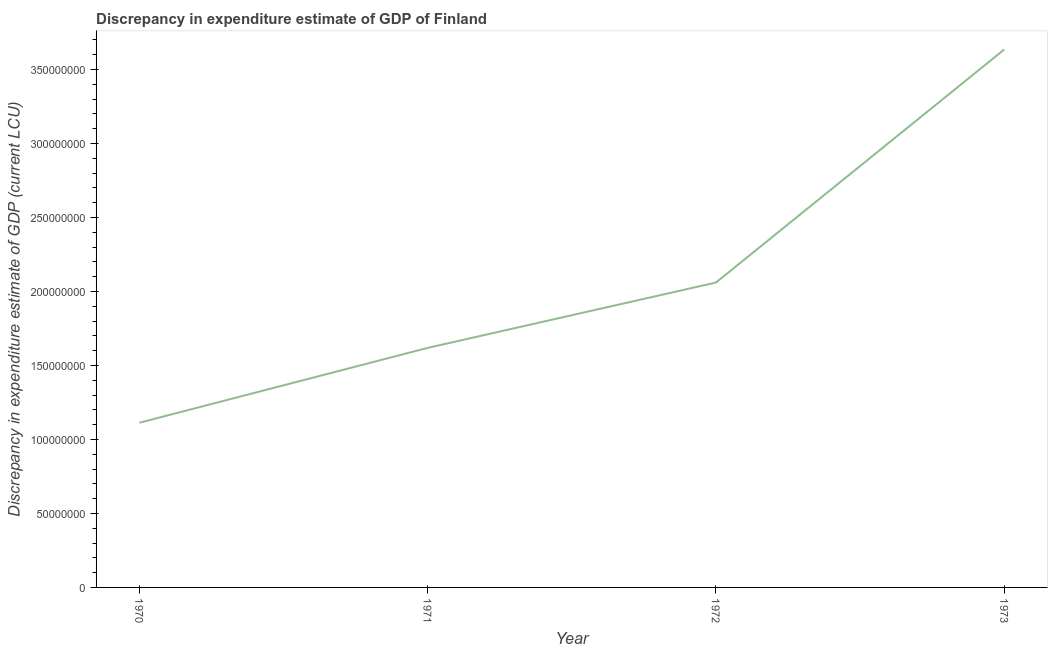What is the discrepancy in expenditure estimate of gdp in 1972?
Give a very brief answer. 2.06e+08. Across all years, what is the maximum discrepancy in expenditure estimate of gdp?
Your answer should be very brief. 3.63e+08. Across all years, what is the minimum discrepancy in expenditure estimate of gdp?
Offer a terse response. 1.11e+08. What is the sum of the discrepancy in expenditure estimate of gdp?
Your answer should be compact. 8.43e+08. What is the difference between the discrepancy in expenditure estimate of gdp in 1970 and 1971?
Your answer should be very brief. -5.06e+07. What is the average discrepancy in expenditure estimate of gdp per year?
Offer a terse response. 2.11e+08. What is the median discrepancy in expenditure estimate of gdp?
Your response must be concise. 1.84e+08. In how many years, is the discrepancy in expenditure estimate of gdp greater than 110000000 LCU?
Ensure brevity in your answer.  4. What is the ratio of the discrepancy in expenditure estimate of gdp in 1971 to that in 1973?
Your answer should be compact. 0.45. Is the discrepancy in expenditure estimate of gdp in 1970 less than that in 1973?
Keep it short and to the point. Yes. What is the difference between the highest and the second highest discrepancy in expenditure estimate of gdp?
Make the answer very short. 1.57e+08. What is the difference between the highest and the lowest discrepancy in expenditure estimate of gdp?
Your answer should be very brief. 2.52e+08. In how many years, is the discrepancy in expenditure estimate of gdp greater than the average discrepancy in expenditure estimate of gdp taken over all years?
Your response must be concise. 1. Does the discrepancy in expenditure estimate of gdp monotonically increase over the years?
Give a very brief answer. Yes. Are the values on the major ticks of Y-axis written in scientific E-notation?
Offer a terse response. No. Does the graph contain grids?
Offer a very short reply. No. What is the title of the graph?
Ensure brevity in your answer.  Discrepancy in expenditure estimate of GDP of Finland. What is the label or title of the Y-axis?
Keep it short and to the point. Discrepancy in expenditure estimate of GDP (current LCU). What is the Discrepancy in expenditure estimate of GDP (current LCU) of 1970?
Your answer should be very brief. 1.11e+08. What is the Discrepancy in expenditure estimate of GDP (current LCU) in 1971?
Your response must be concise. 1.62e+08. What is the Discrepancy in expenditure estimate of GDP (current LCU) of 1972?
Ensure brevity in your answer.  2.06e+08. What is the Discrepancy in expenditure estimate of GDP (current LCU) in 1973?
Keep it short and to the point. 3.63e+08. What is the difference between the Discrepancy in expenditure estimate of GDP (current LCU) in 1970 and 1971?
Ensure brevity in your answer.  -5.06e+07. What is the difference between the Discrepancy in expenditure estimate of GDP (current LCU) in 1970 and 1972?
Give a very brief answer. -9.47e+07. What is the difference between the Discrepancy in expenditure estimate of GDP (current LCU) in 1970 and 1973?
Offer a terse response. -2.52e+08. What is the difference between the Discrepancy in expenditure estimate of GDP (current LCU) in 1971 and 1972?
Ensure brevity in your answer.  -4.42e+07. What is the difference between the Discrepancy in expenditure estimate of GDP (current LCU) in 1971 and 1973?
Offer a terse response. -2.02e+08. What is the difference between the Discrepancy in expenditure estimate of GDP (current LCU) in 1972 and 1973?
Your answer should be very brief. -1.57e+08. What is the ratio of the Discrepancy in expenditure estimate of GDP (current LCU) in 1970 to that in 1971?
Your response must be concise. 0.69. What is the ratio of the Discrepancy in expenditure estimate of GDP (current LCU) in 1970 to that in 1972?
Your answer should be very brief. 0.54. What is the ratio of the Discrepancy in expenditure estimate of GDP (current LCU) in 1970 to that in 1973?
Keep it short and to the point. 0.31. What is the ratio of the Discrepancy in expenditure estimate of GDP (current LCU) in 1971 to that in 1972?
Ensure brevity in your answer.  0.79. What is the ratio of the Discrepancy in expenditure estimate of GDP (current LCU) in 1971 to that in 1973?
Offer a very short reply. 0.45. What is the ratio of the Discrepancy in expenditure estimate of GDP (current LCU) in 1972 to that in 1973?
Make the answer very short. 0.57. 